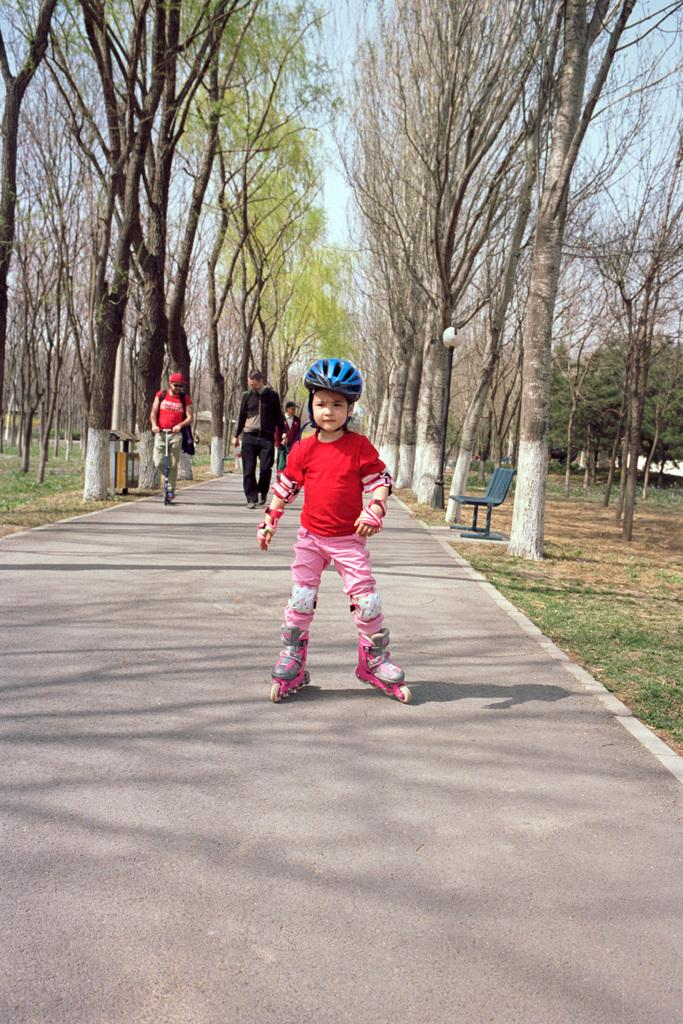Who or what can be seen in the image? There are people in the image. What type of surface is visible beneath the people? The ground is visible in the image. What kind of vegetation is present in the image? There is grass in the image. Is there any seating visible in the image? Yes, there is a bench in the image. What else can be seen in the background of the image? There are trees and the sky visible in the image. What type of store can be seen in the image? There is no store present in the image. How many sons are visible in the image? There is no mention of a son or sons in the image. 